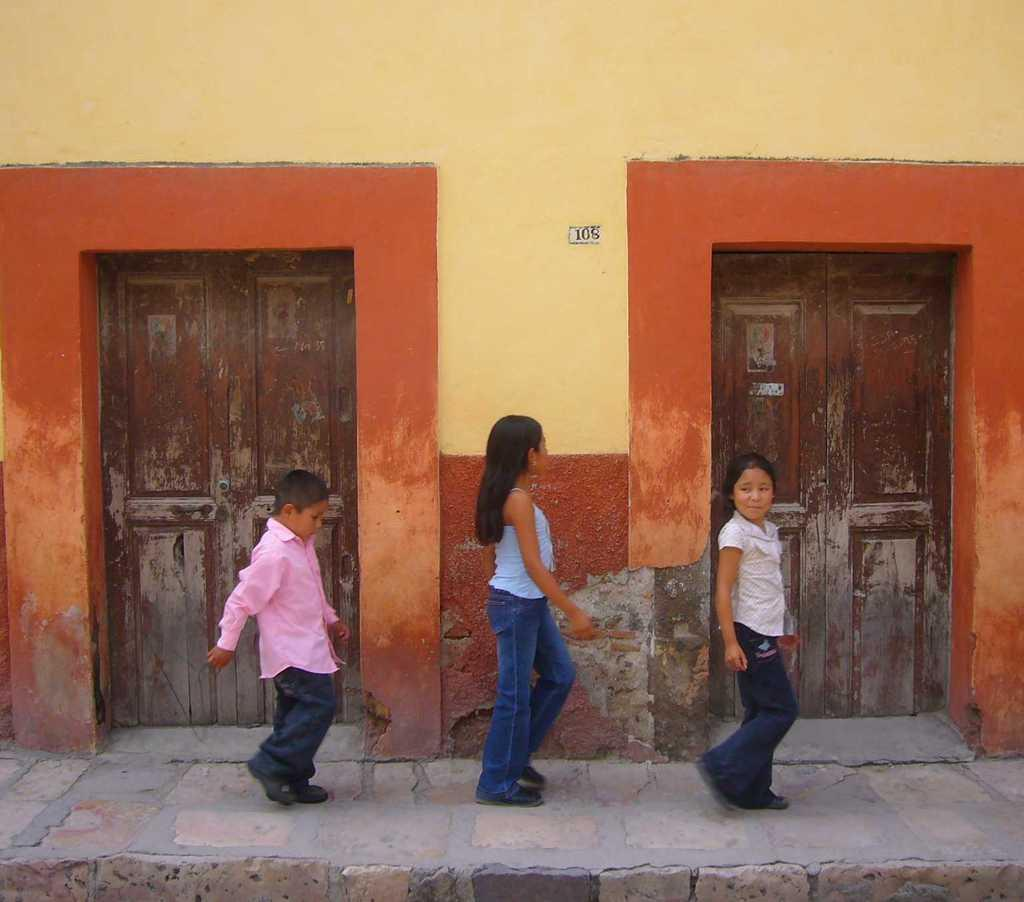How many kids are in the image? There are three kids in the image. What are the kids doing in the image? The kids are walking on a footpath. Where is the footpath located in relation to the building? The footpath is in front of a building. How many doors does the building have? The building has two doors, one on either side. Can you tell me how many beggars are standing near the building in the image? There is no mention of any beggars in the image; it only features three kids walking on a footpath in front of a building with two doors. 